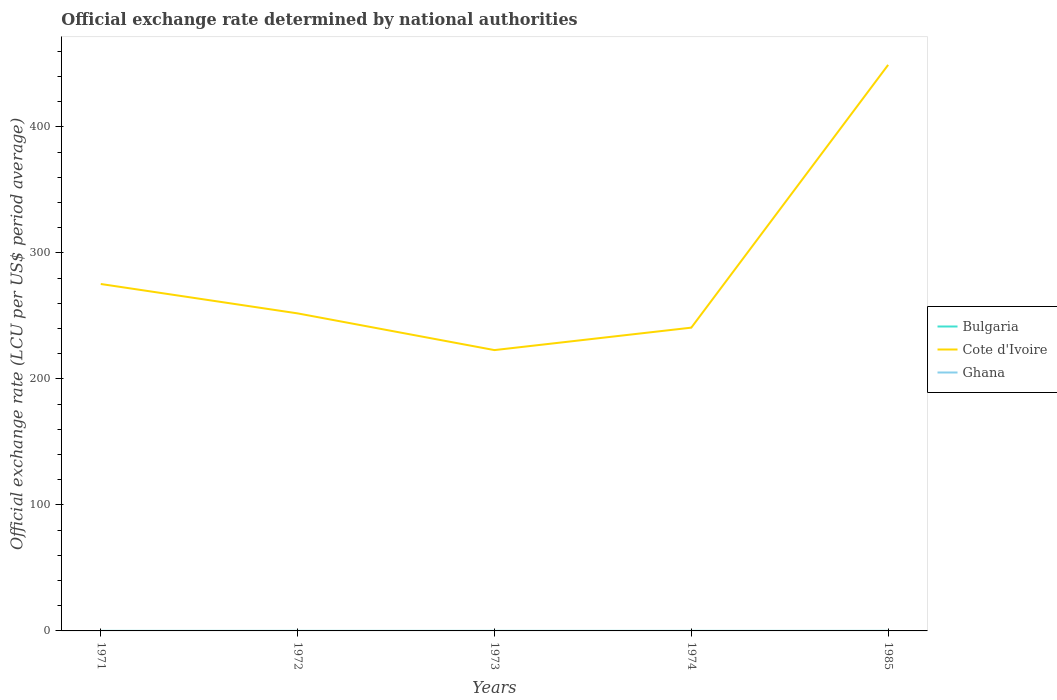How many different coloured lines are there?
Your response must be concise. 3. Across all years, what is the maximum official exchange rate in Bulgaria?
Make the answer very short. 0. In which year was the official exchange rate in Ghana maximum?
Offer a very short reply. 1971. What is the total official exchange rate in Cote d'Ivoire in the graph?
Give a very brief answer. 23.33. What is the difference between the highest and the second highest official exchange rate in Ghana?
Keep it short and to the point. 0.01. What is the difference between the highest and the lowest official exchange rate in Ghana?
Provide a short and direct response. 1. Is the official exchange rate in Cote d'Ivoire strictly greater than the official exchange rate in Bulgaria over the years?
Keep it short and to the point. No. How many lines are there?
Provide a short and direct response. 3. How many years are there in the graph?
Offer a very short reply. 5. Does the graph contain grids?
Your answer should be very brief. No. Where does the legend appear in the graph?
Provide a short and direct response. Center right. How are the legend labels stacked?
Ensure brevity in your answer.  Vertical. What is the title of the graph?
Give a very brief answer. Official exchange rate determined by national authorities. What is the label or title of the X-axis?
Your answer should be compact. Years. What is the label or title of the Y-axis?
Provide a succinct answer. Official exchange rate (LCU per US$ period average). What is the Official exchange rate (LCU per US$ period average) of Bulgaria in 1971?
Provide a short and direct response. 0. What is the Official exchange rate (LCU per US$ period average) of Cote d'Ivoire in 1971?
Make the answer very short. 275.36. What is the Official exchange rate (LCU per US$ period average) of Ghana in 1971?
Your response must be concise. 0. What is the Official exchange rate (LCU per US$ period average) in Bulgaria in 1972?
Offer a terse response. 0. What is the Official exchange rate (LCU per US$ period average) in Cote d'Ivoire in 1972?
Ensure brevity in your answer.  252.03. What is the Official exchange rate (LCU per US$ period average) of Ghana in 1972?
Provide a short and direct response. 0. What is the Official exchange rate (LCU per US$ period average) in Bulgaria in 1973?
Keep it short and to the point. 0. What is the Official exchange rate (LCU per US$ period average) in Cote d'Ivoire in 1973?
Give a very brief answer. 222.89. What is the Official exchange rate (LCU per US$ period average) of Ghana in 1973?
Your answer should be very brief. 0. What is the Official exchange rate (LCU per US$ period average) of Bulgaria in 1974?
Offer a terse response. 0. What is the Official exchange rate (LCU per US$ period average) in Cote d'Ivoire in 1974?
Your response must be concise. 240.7. What is the Official exchange rate (LCU per US$ period average) of Ghana in 1974?
Your response must be concise. 0. What is the Official exchange rate (LCU per US$ period average) of Bulgaria in 1985?
Your answer should be compact. 0. What is the Official exchange rate (LCU per US$ period average) in Cote d'Ivoire in 1985?
Give a very brief answer. 449.26. What is the Official exchange rate (LCU per US$ period average) of Ghana in 1985?
Offer a very short reply. 0.01. Across all years, what is the maximum Official exchange rate (LCU per US$ period average) of Bulgaria?
Your answer should be very brief. 0. Across all years, what is the maximum Official exchange rate (LCU per US$ period average) in Cote d'Ivoire?
Your answer should be compact. 449.26. Across all years, what is the maximum Official exchange rate (LCU per US$ period average) of Ghana?
Your answer should be very brief. 0.01. Across all years, what is the minimum Official exchange rate (LCU per US$ period average) in Bulgaria?
Your answer should be compact. 0. Across all years, what is the minimum Official exchange rate (LCU per US$ period average) of Cote d'Ivoire?
Provide a short and direct response. 222.89. Across all years, what is the minimum Official exchange rate (LCU per US$ period average) in Ghana?
Your answer should be compact. 0. What is the total Official exchange rate (LCU per US$ period average) of Bulgaria in the graph?
Your answer should be compact. 0.01. What is the total Official exchange rate (LCU per US$ period average) in Cote d'Ivoire in the graph?
Provide a succinct answer. 1440.24. What is the total Official exchange rate (LCU per US$ period average) in Ghana in the graph?
Keep it short and to the point. 0.01. What is the difference between the Official exchange rate (LCU per US$ period average) in Bulgaria in 1971 and that in 1972?
Your answer should be compact. 0. What is the difference between the Official exchange rate (LCU per US$ period average) of Cote d'Ivoire in 1971 and that in 1972?
Make the answer very short. 23.33. What is the difference between the Official exchange rate (LCU per US$ period average) of Ghana in 1971 and that in 1972?
Offer a terse response. -0. What is the difference between the Official exchange rate (LCU per US$ period average) of Bulgaria in 1971 and that in 1973?
Provide a short and direct response. 0. What is the difference between the Official exchange rate (LCU per US$ period average) of Cote d'Ivoire in 1971 and that in 1973?
Provide a succinct answer. 52.47. What is the difference between the Official exchange rate (LCU per US$ period average) of Bulgaria in 1971 and that in 1974?
Offer a terse response. 0. What is the difference between the Official exchange rate (LCU per US$ period average) of Cote d'Ivoire in 1971 and that in 1974?
Offer a terse response. 34.65. What is the difference between the Official exchange rate (LCU per US$ period average) in Bulgaria in 1971 and that in 1985?
Provide a succinct answer. 0. What is the difference between the Official exchange rate (LCU per US$ period average) of Cote d'Ivoire in 1971 and that in 1985?
Your answer should be very brief. -173.91. What is the difference between the Official exchange rate (LCU per US$ period average) in Ghana in 1971 and that in 1985?
Make the answer very short. -0.01. What is the difference between the Official exchange rate (LCU per US$ period average) of Cote d'Ivoire in 1972 and that in 1973?
Provide a succinct answer. 29.14. What is the difference between the Official exchange rate (LCU per US$ period average) of Ghana in 1972 and that in 1973?
Keep it short and to the point. 0. What is the difference between the Official exchange rate (LCU per US$ period average) in Cote d'Ivoire in 1972 and that in 1974?
Provide a short and direct response. 11.32. What is the difference between the Official exchange rate (LCU per US$ period average) of Cote d'Ivoire in 1972 and that in 1985?
Give a very brief answer. -197.24. What is the difference between the Official exchange rate (LCU per US$ period average) in Ghana in 1972 and that in 1985?
Provide a short and direct response. -0.01. What is the difference between the Official exchange rate (LCU per US$ period average) of Bulgaria in 1973 and that in 1974?
Offer a terse response. 0. What is the difference between the Official exchange rate (LCU per US$ period average) of Cote d'Ivoire in 1973 and that in 1974?
Make the answer very short. -17.82. What is the difference between the Official exchange rate (LCU per US$ period average) of Bulgaria in 1973 and that in 1985?
Provide a short and direct response. -0. What is the difference between the Official exchange rate (LCU per US$ period average) in Cote d'Ivoire in 1973 and that in 1985?
Make the answer very short. -226.37. What is the difference between the Official exchange rate (LCU per US$ period average) in Ghana in 1973 and that in 1985?
Give a very brief answer. -0.01. What is the difference between the Official exchange rate (LCU per US$ period average) of Bulgaria in 1974 and that in 1985?
Offer a terse response. -0. What is the difference between the Official exchange rate (LCU per US$ period average) of Cote d'Ivoire in 1974 and that in 1985?
Provide a short and direct response. -208.56. What is the difference between the Official exchange rate (LCU per US$ period average) in Ghana in 1974 and that in 1985?
Offer a very short reply. -0.01. What is the difference between the Official exchange rate (LCU per US$ period average) in Bulgaria in 1971 and the Official exchange rate (LCU per US$ period average) in Cote d'Ivoire in 1972?
Your answer should be compact. -252.03. What is the difference between the Official exchange rate (LCU per US$ period average) in Cote d'Ivoire in 1971 and the Official exchange rate (LCU per US$ period average) in Ghana in 1972?
Your response must be concise. 275.36. What is the difference between the Official exchange rate (LCU per US$ period average) of Bulgaria in 1971 and the Official exchange rate (LCU per US$ period average) of Cote d'Ivoire in 1973?
Keep it short and to the point. -222.89. What is the difference between the Official exchange rate (LCU per US$ period average) of Bulgaria in 1971 and the Official exchange rate (LCU per US$ period average) of Ghana in 1973?
Offer a very short reply. 0. What is the difference between the Official exchange rate (LCU per US$ period average) in Cote d'Ivoire in 1971 and the Official exchange rate (LCU per US$ period average) in Ghana in 1973?
Provide a short and direct response. 275.36. What is the difference between the Official exchange rate (LCU per US$ period average) of Bulgaria in 1971 and the Official exchange rate (LCU per US$ period average) of Cote d'Ivoire in 1974?
Ensure brevity in your answer.  -240.7. What is the difference between the Official exchange rate (LCU per US$ period average) in Bulgaria in 1971 and the Official exchange rate (LCU per US$ period average) in Ghana in 1974?
Provide a succinct answer. 0. What is the difference between the Official exchange rate (LCU per US$ period average) of Cote d'Ivoire in 1971 and the Official exchange rate (LCU per US$ period average) of Ghana in 1974?
Make the answer very short. 275.36. What is the difference between the Official exchange rate (LCU per US$ period average) of Bulgaria in 1971 and the Official exchange rate (LCU per US$ period average) of Cote d'Ivoire in 1985?
Offer a very short reply. -449.26. What is the difference between the Official exchange rate (LCU per US$ period average) in Bulgaria in 1971 and the Official exchange rate (LCU per US$ period average) in Ghana in 1985?
Provide a short and direct response. -0. What is the difference between the Official exchange rate (LCU per US$ period average) in Cote d'Ivoire in 1971 and the Official exchange rate (LCU per US$ period average) in Ghana in 1985?
Provide a succinct answer. 275.35. What is the difference between the Official exchange rate (LCU per US$ period average) in Bulgaria in 1972 and the Official exchange rate (LCU per US$ period average) in Cote d'Ivoire in 1973?
Offer a very short reply. -222.89. What is the difference between the Official exchange rate (LCU per US$ period average) in Cote d'Ivoire in 1972 and the Official exchange rate (LCU per US$ period average) in Ghana in 1973?
Your answer should be very brief. 252.03. What is the difference between the Official exchange rate (LCU per US$ period average) in Bulgaria in 1972 and the Official exchange rate (LCU per US$ period average) in Cote d'Ivoire in 1974?
Provide a short and direct response. -240.7. What is the difference between the Official exchange rate (LCU per US$ period average) in Cote d'Ivoire in 1972 and the Official exchange rate (LCU per US$ period average) in Ghana in 1974?
Make the answer very short. 252.03. What is the difference between the Official exchange rate (LCU per US$ period average) in Bulgaria in 1972 and the Official exchange rate (LCU per US$ period average) in Cote d'Ivoire in 1985?
Provide a short and direct response. -449.26. What is the difference between the Official exchange rate (LCU per US$ period average) in Bulgaria in 1972 and the Official exchange rate (LCU per US$ period average) in Ghana in 1985?
Your answer should be compact. -0. What is the difference between the Official exchange rate (LCU per US$ period average) of Cote d'Ivoire in 1972 and the Official exchange rate (LCU per US$ period average) of Ghana in 1985?
Ensure brevity in your answer.  252.02. What is the difference between the Official exchange rate (LCU per US$ period average) in Bulgaria in 1973 and the Official exchange rate (LCU per US$ period average) in Cote d'Ivoire in 1974?
Offer a terse response. -240.7. What is the difference between the Official exchange rate (LCU per US$ period average) in Bulgaria in 1973 and the Official exchange rate (LCU per US$ period average) in Ghana in 1974?
Provide a short and direct response. 0. What is the difference between the Official exchange rate (LCU per US$ period average) of Cote d'Ivoire in 1973 and the Official exchange rate (LCU per US$ period average) of Ghana in 1974?
Your response must be concise. 222.89. What is the difference between the Official exchange rate (LCU per US$ period average) of Bulgaria in 1973 and the Official exchange rate (LCU per US$ period average) of Cote d'Ivoire in 1985?
Ensure brevity in your answer.  -449.26. What is the difference between the Official exchange rate (LCU per US$ period average) of Bulgaria in 1973 and the Official exchange rate (LCU per US$ period average) of Ghana in 1985?
Your answer should be compact. -0. What is the difference between the Official exchange rate (LCU per US$ period average) of Cote d'Ivoire in 1973 and the Official exchange rate (LCU per US$ period average) of Ghana in 1985?
Make the answer very short. 222.88. What is the difference between the Official exchange rate (LCU per US$ period average) in Bulgaria in 1974 and the Official exchange rate (LCU per US$ period average) in Cote d'Ivoire in 1985?
Give a very brief answer. -449.26. What is the difference between the Official exchange rate (LCU per US$ period average) in Bulgaria in 1974 and the Official exchange rate (LCU per US$ period average) in Ghana in 1985?
Keep it short and to the point. -0. What is the difference between the Official exchange rate (LCU per US$ period average) of Cote d'Ivoire in 1974 and the Official exchange rate (LCU per US$ period average) of Ghana in 1985?
Keep it short and to the point. 240.7. What is the average Official exchange rate (LCU per US$ period average) in Bulgaria per year?
Offer a very short reply. 0. What is the average Official exchange rate (LCU per US$ period average) in Cote d'Ivoire per year?
Offer a terse response. 288.05. What is the average Official exchange rate (LCU per US$ period average) of Ghana per year?
Provide a short and direct response. 0. In the year 1971, what is the difference between the Official exchange rate (LCU per US$ period average) of Bulgaria and Official exchange rate (LCU per US$ period average) of Cote d'Ivoire?
Your answer should be very brief. -275.36. In the year 1971, what is the difference between the Official exchange rate (LCU per US$ period average) in Bulgaria and Official exchange rate (LCU per US$ period average) in Ghana?
Offer a very short reply. 0. In the year 1971, what is the difference between the Official exchange rate (LCU per US$ period average) in Cote d'Ivoire and Official exchange rate (LCU per US$ period average) in Ghana?
Ensure brevity in your answer.  275.36. In the year 1972, what is the difference between the Official exchange rate (LCU per US$ period average) in Bulgaria and Official exchange rate (LCU per US$ period average) in Cote d'Ivoire?
Give a very brief answer. -252.03. In the year 1972, what is the difference between the Official exchange rate (LCU per US$ period average) of Bulgaria and Official exchange rate (LCU per US$ period average) of Ghana?
Ensure brevity in your answer.  0. In the year 1972, what is the difference between the Official exchange rate (LCU per US$ period average) in Cote d'Ivoire and Official exchange rate (LCU per US$ period average) in Ghana?
Make the answer very short. 252.03. In the year 1973, what is the difference between the Official exchange rate (LCU per US$ period average) of Bulgaria and Official exchange rate (LCU per US$ period average) of Cote d'Ivoire?
Your answer should be very brief. -222.89. In the year 1973, what is the difference between the Official exchange rate (LCU per US$ period average) of Bulgaria and Official exchange rate (LCU per US$ period average) of Ghana?
Offer a very short reply. 0. In the year 1973, what is the difference between the Official exchange rate (LCU per US$ period average) in Cote d'Ivoire and Official exchange rate (LCU per US$ period average) in Ghana?
Ensure brevity in your answer.  222.89. In the year 1974, what is the difference between the Official exchange rate (LCU per US$ period average) of Bulgaria and Official exchange rate (LCU per US$ period average) of Cote d'Ivoire?
Provide a succinct answer. -240.7. In the year 1974, what is the difference between the Official exchange rate (LCU per US$ period average) in Bulgaria and Official exchange rate (LCU per US$ period average) in Ghana?
Offer a terse response. 0. In the year 1974, what is the difference between the Official exchange rate (LCU per US$ period average) of Cote d'Ivoire and Official exchange rate (LCU per US$ period average) of Ghana?
Provide a succinct answer. 240.7. In the year 1985, what is the difference between the Official exchange rate (LCU per US$ period average) in Bulgaria and Official exchange rate (LCU per US$ period average) in Cote d'Ivoire?
Your answer should be compact. -449.26. In the year 1985, what is the difference between the Official exchange rate (LCU per US$ period average) in Bulgaria and Official exchange rate (LCU per US$ period average) in Ghana?
Your answer should be very brief. -0. In the year 1985, what is the difference between the Official exchange rate (LCU per US$ period average) in Cote d'Ivoire and Official exchange rate (LCU per US$ period average) in Ghana?
Offer a terse response. 449.26. What is the ratio of the Official exchange rate (LCU per US$ period average) in Cote d'Ivoire in 1971 to that in 1972?
Your response must be concise. 1.09. What is the ratio of the Official exchange rate (LCU per US$ period average) in Ghana in 1971 to that in 1972?
Provide a succinct answer. 0.78. What is the ratio of the Official exchange rate (LCU per US$ period average) in Bulgaria in 1971 to that in 1973?
Ensure brevity in your answer.  1.19. What is the ratio of the Official exchange rate (LCU per US$ period average) of Cote d'Ivoire in 1971 to that in 1973?
Offer a very short reply. 1.24. What is the ratio of the Official exchange rate (LCU per US$ period average) of Ghana in 1971 to that in 1973?
Your answer should be compact. 0.89. What is the ratio of the Official exchange rate (LCU per US$ period average) of Bulgaria in 1971 to that in 1974?
Make the answer very short. 1.21. What is the ratio of the Official exchange rate (LCU per US$ period average) in Cote d'Ivoire in 1971 to that in 1974?
Your answer should be very brief. 1.14. What is the ratio of the Official exchange rate (LCU per US$ period average) in Ghana in 1971 to that in 1974?
Your answer should be compact. 0.9. What is the ratio of the Official exchange rate (LCU per US$ period average) in Bulgaria in 1971 to that in 1985?
Offer a very short reply. 1.14. What is the ratio of the Official exchange rate (LCU per US$ period average) of Cote d'Ivoire in 1971 to that in 1985?
Your answer should be compact. 0.61. What is the ratio of the Official exchange rate (LCU per US$ period average) of Ghana in 1971 to that in 1985?
Your answer should be very brief. 0.02. What is the ratio of the Official exchange rate (LCU per US$ period average) of Bulgaria in 1972 to that in 1973?
Make the answer very short. 1.1. What is the ratio of the Official exchange rate (LCU per US$ period average) in Cote d'Ivoire in 1972 to that in 1973?
Your answer should be very brief. 1.13. What is the ratio of the Official exchange rate (LCU per US$ period average) of Ghana in 1972 to that in 1973?
Offer a very short reply. 1.14. What is the ratio of the Official exchange rate (LCU per US$ period average) of Bulgaria in 1972 to that in 1974?
Make the answer very short. 1.11. What is the ratio of the Official exchange rate (LCU per US$ period average) of Cote d'Ivoire in 1972 to that in 1974?
Keep it short and to the point. 1.05. What is the ratio of the Official exchange rate (LCU per US$ period average) of Ghana in 1972 to that in 1974?
Give a very brief answer. 1.16. What is the ratio of the Official exchange rate (LCU per US$ period average) of Bulgaria in 1972 to that in 1985?
Offer a very short reply. 1.05. What is the ratio of the Official exchange rate (LCU per US$ period average) of Cote d'Ivoire in 1972 to that in 1985?
Your response must be concise. 0.56. What is the ratio of the Official exchange rate (LCU per US$ period average) of Ghana in 1972 to that in 1985?
Offer a very short reply. 0.02. What is the ratio of the Official exchange rate (LCU per US$ period average) of Bulgaria in 1973 to that in 1974?
Ensure brevity in your answer.  1.01. What is the ratio of the Official exchange rate (LCU per US$ period average) in Cote d'Ivoire in 1973 to that in 1974?
Your answer should be compact. 0.93. What is the ratio of the Official exchange rate (LCU per US$ period average) of Ghana in 1973 to that in 1974?
Your response must be concise. 1.01. What is the ratio of the Official exchange rate (LCU per US$ period average) in Bulgaria in 1973 to that in 1985?
Provide a short and direct response. 0.95. What is the ratio of the Official exchange rate (LCU per US$ period average) of Cote d'Ivoire in 1973 to that in 1985?
Your response must be concise. 0.5. What is the ratio of the Official exchange rate (LCU per US$ period average) in Ghana in 1973 to that in 1985?
Provide a succinct answer. 0.02. What is the ratio of the Official exchange rate (LCU per US$ period average) in Bulgaria in 1974 to that in 1985?
Offer a very short reply. 0.94. What is the ratio of the Official exchange rate (LCU per US$ period average) of Cote d'Ivoire in 1974 to that in 1985?
Make the answer very short. 0.54. What is the ratio of the Official exchange rate (LCU per US$ period average) in Ghana in 1974 to that in 1985?
Provide a short and direct response. 0.02. What is the difference between the highest and the second highest Official exchange rate (LCU per US$ period average) in Bulgaria?
Keep it short and to the point. 0. What is the difference between the highest and the second highest Official exchange rate (LCU per US$ period average) of Cote d'Ivoire?
Ensure brevity in your answer.  173.91. What is the difference between the highest and the second highest Official exchange rate (LCU per US$ period average) in Ghana?
Give a very brief answer. 0.01. What is the difference between the highest and the lowest Official exchange rate (LCU per US$ period average) of Bulgaria?
Your answer should be very brief. 0. What is the difference between the highest and the lowest Official exchange rate (LCU per US$ period average) in Cote d'Ivoire?
Keep it short and to the point. 226.37. What is the difference between the highest and the lowest Official exchange rate (LCU per US$ period average) in Ghana?
Keep it short and to the point. 0.01. 